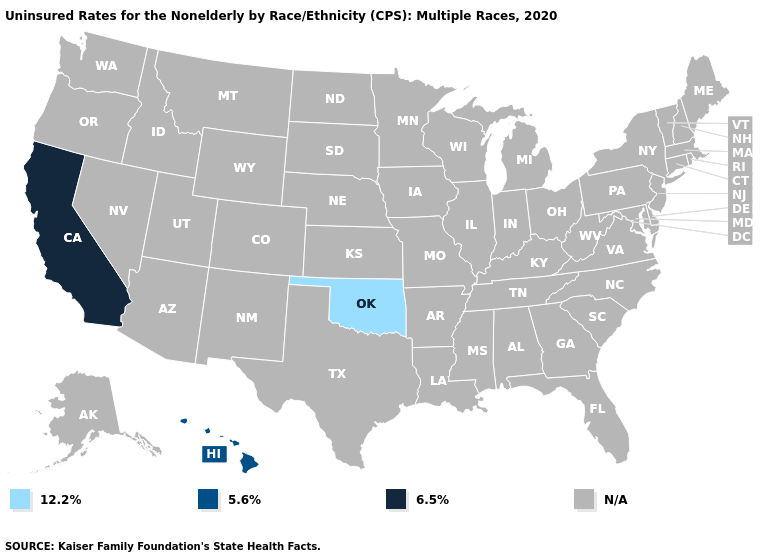Does the first symbol in the legend represent the smallest category?
Answer briefly. Yes. Name the states that have a value in the range 6.5%?
Quick response, please. California. Name the states that have a value in the range 12.2%?
Keep it brief. Oklahoma. What is the value of Virginia?
Keep it brief. N/A. Which states have the lowest value in the USA?
Keep it brief. Oklahoma. Is the legend a continuous bar?
Concise answer only. No. Name the states that have a value in the range N/A?
Concise answer only. Alabama, Alaska, Arizona, Arkansas, Colorado, Connecticut, Delaware, Florida, Georgia, Idaho, Illinois, Indiana, Iowa, Kansas, Kentucky, Louisiana, Maine, Maryland, Massachusetts, Michigan, Minnesota, Mississippi, Missouri, Montana, Nebraska, Nevada, New Hampshire, New Jersey, New Mexico, New York, North Carolina, North Dakota, Ohio, Oregon, Pennsylvania, Rhode Island, South Carolina, South Dakota, Tennessee, Texas, Utah, Vermont, Virginia, Washington, West Virginia, Wisconsin, Wyoming. Name the states that have a value in the range 5.6%?
Short answer required. Hawaii. 